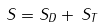<formula> <loc_0><loc_0><loc_500><loc_500>S = S _ { D } + \, S _ { T } \,</formula> 